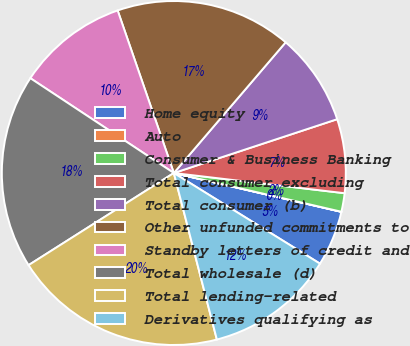<chart> <loc_0><loc_0><loc_500><loc_500><pie_chart><fcel>Home equity<fcel>Auto<fcel>Consumer & Business Banking<fcel>Total consumer excluding<fcel>Total consumer (b)<fcel>Other unfunded commitments to<fcel>Standby letters of credit and<fcel>Total wholesale (d)<fcel>Total lending-related<fcel>Derivatives qualifying as<nl><fcel>5.21%<fcel>0.01%<fcel>1.74%<fcel>6.94%<fcel>8.67%<fcel>16.56%<fcel>10.41%<fcel>18.29%<fcel>20.03%<fcel>12.14%<nl></chart> 